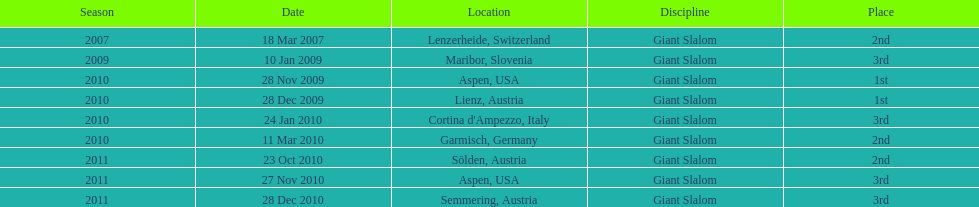Where was her first win? Aspen, USA. 